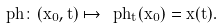Convert formula to latex. <formula><loc_0><loc_0><loc_500><loc_500>\ p h \colon ( x _ { 0 } , t ) \mapsto \ p h _ { t } ( x _ { 0 } ) = x ( t ) .</formula> 